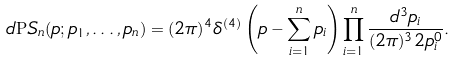Convert formula to latex. <formula><loc_0><loc_0><loc_500><loc_500>d { \mathrm P S } _ { n } ( p ; p _ { 1 } , \dots , p _ { n } ) = ( 2 \pi ) ^ { 4 } \delta ^ { ( 4 ) } \left ( p - \sum _ { i = 1 } ^ { n } p _ { i } \right ) \prod _ { i = 1 } ^ { n } \frac { d ^ { 3 } p _ { i } } { ( 2 \pi ) ^ { 3 } 2 p _ { i } ^ { 0 } } .</formula> 